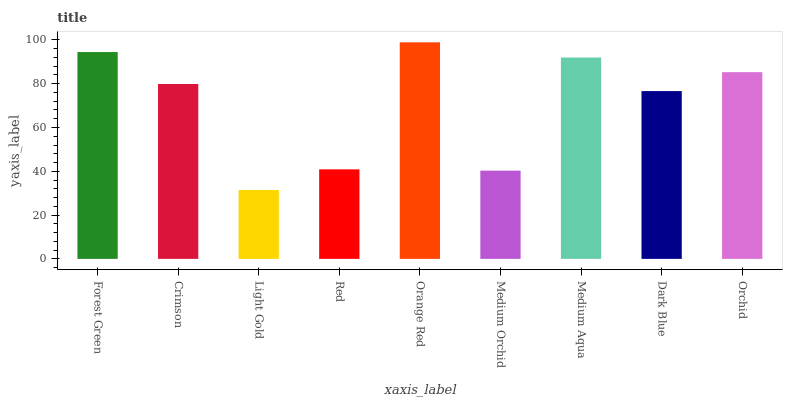Is Light Gold the minimum?
Answer yes or no. Yes. Is Orange Red the maximum?
Answer yes or no. Yes. Is Crimson the minimum?
Answer yes or no. No. Is Crimson the maximum?
Answer yes or no. No. Is Forest Green greater than Crimson?
Answer yes or no. Yes. Is Crimson less than Forest Green?
Answer yes or no. Yes. Is Crimson greater than Forest Green?
Answer yes or no. No. Is Forest Green less than Crimson?
Answer yes or no. No. Is Crimson the high median?
Answer yes or no. Yes. Is Crimson the low median?
Answer yes or no. Yes. Is Medium Orchid the high median?
Answer yes or no. No. Is Medium Orchid the low median?
Answer yes or no. No. 